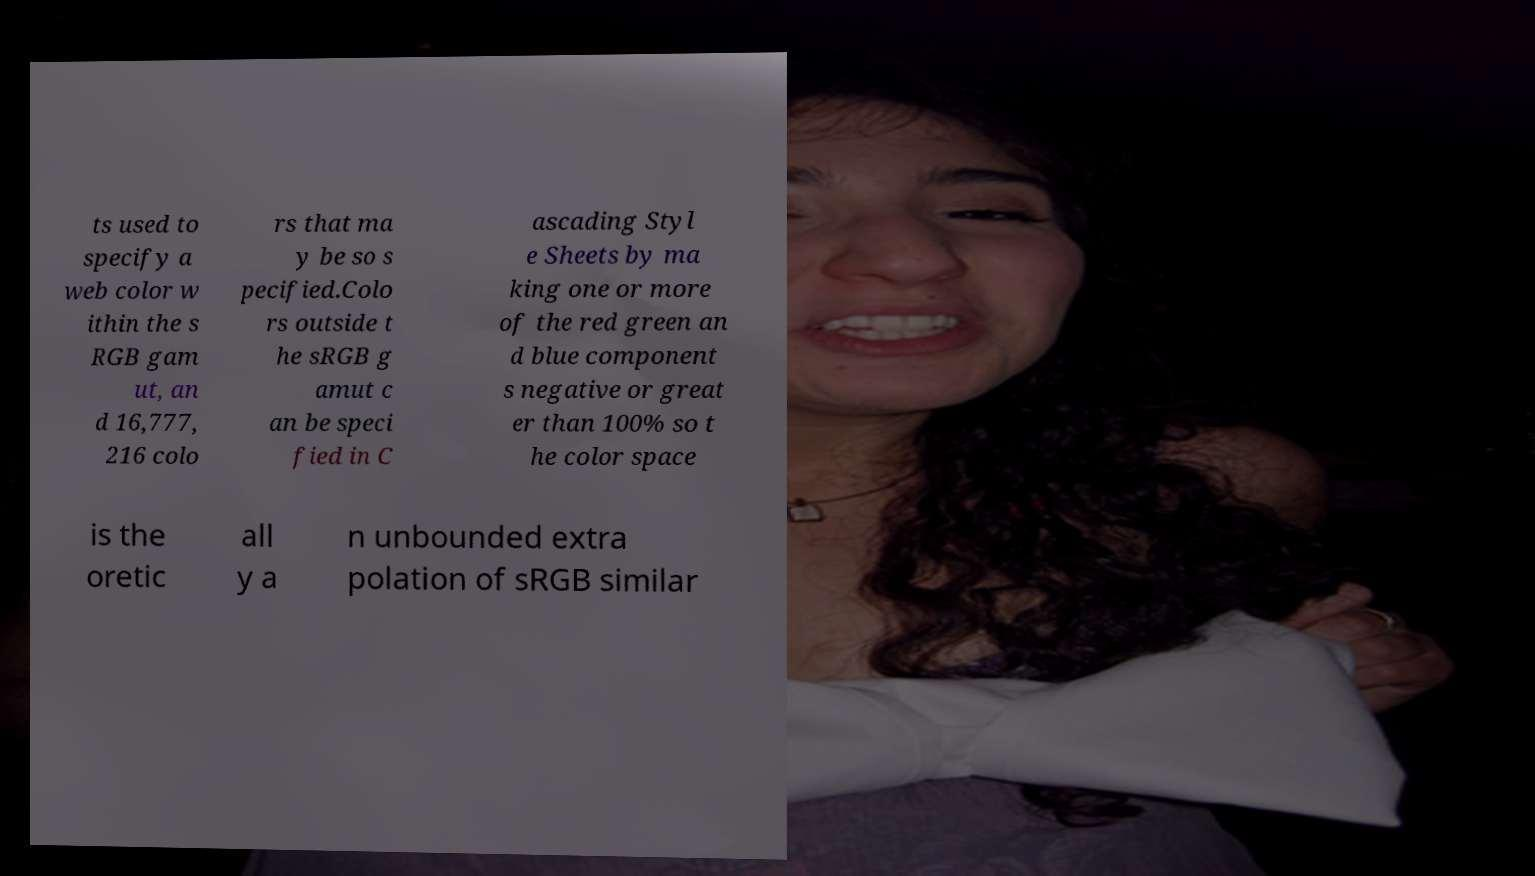There's text embedded in this image that I need extracted. Can you transcribe it verbatim? ts used to specify a web color w ithin the s RGB gam ut, an d 16,777, 216 colo rs that ma y be so s pecified.Colo rs outside t he sRGB g amut c an be speci fied in C ascading Styl e Sheets by ma king one or more of the red green an d blue component s negative or great er than 100% so t he color space is the oretic all y a n unbounded extra polation of sRGB similar 